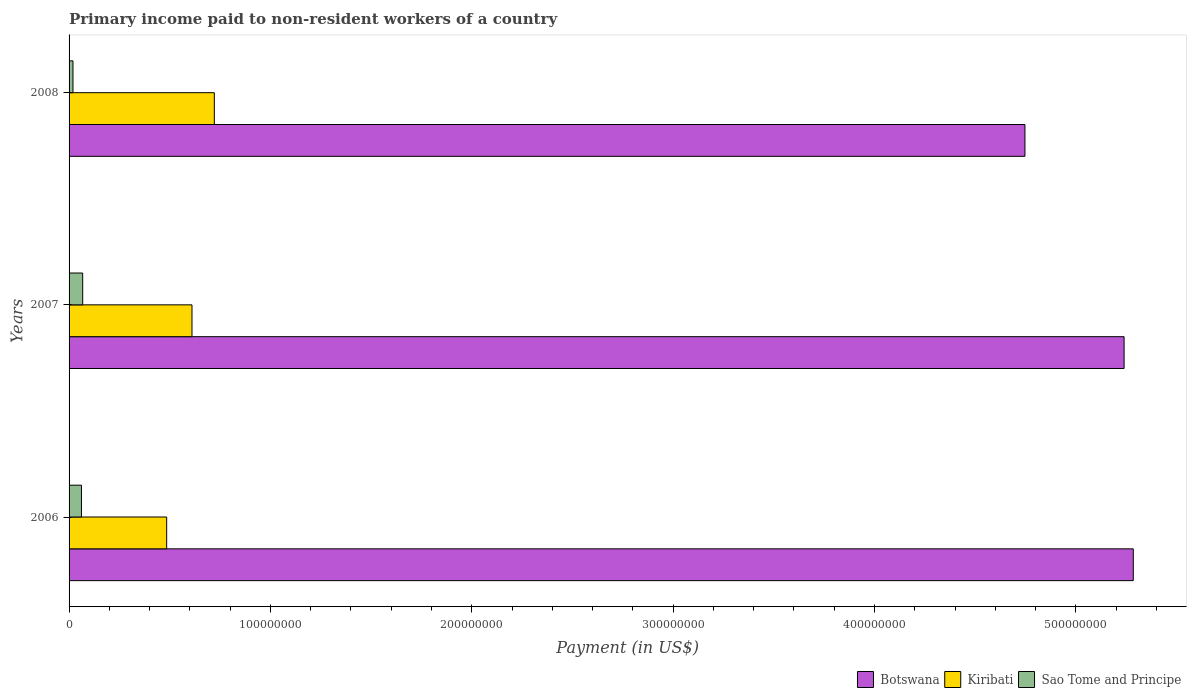How many different coloured bars are there?
Offer a terse response. 3. Are the number of bars per tick equal to the number of legend labels?
Keep it short and to the point. Yes. How many bars are there on the 3rd tick from the top?
Keep it short and to the point. 3. How many bars are there on the 3rd tick from the bottom?
Give a very brief answer. 3. In how many cases, is the number of bars for a given year not equal to the number of legend labels?
Your answer should be very brief. 0. What is the amount paid to workers in Sao Tome and Principe in 2007?
Your response must be concise. 6.76e+06. Across all years, what is the maximum amount paid to workers in Kiribati?
Keep it short and to the point. 7.21e+07. Across all years, what is the minimum amount paid to workers in Botswana?
Offer a very short reply. 4.75e+08. What is the total amount paid to workers in Kiribati in the graph?
Make the answer very short. 1.82e+08. What is the difference between the amount paid to workers in Sao Tome and Principe in 2006 and that in 2007?
Give a very brief answer. -6.11e+05. What is the difference between the amount paid to workers in Botswana in 2008 and the amount paid to workers in Kiribati in 2007?
Your answer should be compact. 4.14e+08. What is the average amount paid to workers in Botswana per year?
Your response must be concise. 5.09e+08. In the year 2006, what is the difference between the amount paid to workers in Botswana and amount paid to workers in Sao Tome and Principe?
Your answer should be compact. 5.22e+08. In how many years, is the amount paid to workers in Sao Tome and Principe greater than 500000000 US$?
Ensure brevity in your answer.  0. What is the ratio of the amount paid to workers in Botswana in 2006 to that in 2008?
Provide a short and direct response. 1.11. Is the amount paid to workers in Sao Tome and Principe in 2006 less than that in 2008?
Offer a very short reply. No. What is the difference between the highest and the second highest amount paid to workers in Botswana?
Give a very brief answer. 4.56e+06. What is the difference between the highest and the lowest amount paid to workers in Kiribati?
Keep it short and to the point. 2.37e+07. Is the sum of the amount paid to workers in Botswana in 2006 and 2007 greater than the maximum amount paid to workers in Kiribati across all years?
Offer a terse response. Yes. What does the 1st bar from the top in 2006 represents?
Provide a succinct answer. Sao Tome and Principe. What does the 2nd bar from the bottom in 2006 represents?
Make the answer very short. Kiribati. Is it the case that in every year, the sum of the amount paid to workers in Kiribati and amount paid to workers in Botswana is greater than the amount paid to workers in Sao Tome and Principe?
Your response must be concise. Yes. How many bars are there?
Ensure brevity in your answer.  9. Are all the bars in the graph horizontal?
Give a very brief answer. Yes. What is the difference between two consecutive major ticks on the X-axis?
Provide a succinct answer. 1.00e+08. Does the graph contain any zero values?
Provide a short and direct response. No. Does the graph contain grids?
Your answer should be compact. No. How many legend labels are there?
Offer a terse response. 3. What is the title of the graph?
Your response must be concise. Primary income paid to non-resident workers of a country. What is the label or title of the X-axis?
Give a very brief answer. Payment (in US$). What is the Payment (in US$) in Botswana in 2006?
Provide a succinct answer. 5.29e+08. What is the Payment (in US$) of Kiribati in 2006?
Provide a succinct answer. 4.85e+07. What is the Payment (in US$) in Sao Tome and Principe in 2006?
Make the answer very short. 6.15e+06. What is the Payment (in US$) of Botswana in 2007?
Your answer should be compact. 5.24e+08. What is the Payment (in US$) in Kiribati in 2007?
Make the answer very short. 6.10e+07. What is the Payment (in US$) in Sao Tome and Principe in 2007?
Provide a succinct answer. 6.76e+06. What is the Payment (in US$) in Botswana in 2008?
Your response must be concise. 4.75e+08. What is the Payment (in US$) of Kiribati in 2008?
Your response must be concise. 7.21e+07. What is the Payment (in US$) in Sao Tome and Principe in 2008?
Offer a terse response. 1.94e+06. Across all years, what is the maximum Payment (in US$) in Botswana?
Your response must be concise. 5.29e+08. Across all years, what is the maximum Payment (in US$) in Kiribati?
Provide a short and direct response. 7.21e+07. Across all years, what is the maximum Payment (in US$) in Sao Tome and Principe?
Provide a succinct answer. 6.76e+06. Across all years, what is the minimum Payment (in US$) in Botswana?
Your response must be concise. 4.75e+08. Across all years, what is the minimum Payment (in US$) in Kiribati?
Offer a very short reply. 4.85e+07. Across all years, what is the minimum Payment (in US$) of Sao Tome and Principe?
Make the answer very short. 1.94e+06. What is the total Payment (in US$) of Botswana in the graph?
Ensure brevity in your answer.  1.53e+09. What is the total Payment (in US$) in Kiribati in the graph?
Offer a terse response. 1.82e+08. What is the total Payment (in US$) in Sao Tome and Principe in the graph?
Make the answer very short. 1.49e+07. What is the difference between the Payment (in US$) in Botswana in 2006 and that in 2007?
Make the answer very short. 4.56e+06. What is the difference between the Payment (in US$) of Kiribati in 2006 and that in 2007?
Provide a short and direct response. -1.26e+07. What is the difference between the Payment (in US$) of Sao Tome and Principe in 2006 and that in 2007?
Provide a short and direct response. -6.11e+05. What is the difference between the Payment (in US$) in Botswana in 2006 and that in 2008?
Provide a succinct answer. 5.38e+07. What is the difference between the Payment (in US$) in Kiribati in 2006 and that in 2008?
Offer a terse response. -2.37e+07. What is the difference between the Payment (in US$) in Sao Tome and Principe in 2006 and that in 2008?
Your answer should be very brief. 4.21e+06. What is the difference between the Payment (in US$) of Botswana in 2007 and that in 2008?
Ensure brevity in your answer.  4.92e+07. What is the difference between the Payment (in US$) in Kiribati in 2007 and that in 2008?
Your answer should be very brief. -1.11e+07. What is the difference between the Payment (in US$) of Sao Tome and Principe in 2007 and that in 2008?
Make the answer very short. 4.83e+06. What is the difference between the Payment (in US$) of Botswana in 2006 and the Payment (in US$) of Kiribati in 2007?
Offer a terse response. 4.68e+08. What is the difference between the Payment (in US$) of Botswana in 2006 and the Payment (in US$) of Sao Tome and Principe in 2007?
Your answer should be very brief. 5.22e+08. What is the difference between the Payment (in US$) of Kiribati in 2006 and the Payment (in US$) of Sao Tome and Principe in 2007?
Provide a short and direct response. 4.17e+07. What is the difference between the Payment (in US$) in Botswana in 2006 and the Payment (in US$) in Kiribati in 2008?
Your answer should be very brief. 4.56e+08. What is the difference between the Payment (in US$) in Botswana in 2006 and the Payment (in US$) in Sao Tome and Principe in 2008?
Give a very brief answer. 5.27e+08. What is the difference between the Payment (in US$) in Kiribati in 2006 and the Payment (in US$) in Sao Tome and Principe in 2008?
Provide a short and direct response. 4.65e+07. What is the difference between the Payment (in US$) in Botswana in 2007 and the Payment (in US$) in Kiribati in 2008?
Offer a terse response. 4.52e+08. What is the difference between the Payment (in US$) in Botswana in 2007 and the Payment (in US$) in Sao Tome and Principe in 2008?
Your response must be concise. 5.22e+08. What is the difference between the Payment (in US$) in Kiribati in 2007 and the Payment (in US$) in Sao Tome and Principe in 2008?
Your answer should be compact. 5.91e+07. What is the average Payment (in US$) in Botswana per year?
Provide a succinct answer. 5.09e+08. What is the average Payment (in US$) of Kiribati per year?
Offer a very short reply. 6.06e+07. What is the average Payment (in US$) in Sao Tome and Principe per year?
Ensure brevity in your answer.  4.95e+06. In the year 2006, what is the difference between the Payment (in US$) of Botswana and Payment (in US$) of Kiribati?
Offer a terse response. 4.80e+08. In the year 2006, what is the difference between the Payment (in US$) of Botswana and Payment (in US$) of Sao Tome and Principe?
Keep it short and to the point. 5.22e+08. In the year 2006, what is the difference between the Payment (in US$) of Kiribati and Payment (in US$) of Sao Tome and Principe?
Keep it short and to the point. 4.23e+07. In the year 2007, what is the difference between the Payment (in US$) in Botswana and Payment (in US$) in Kiribati?
Ensure brevity in your answer.  4.63e+08. In the year 2007, what is the difference between the Payment (in US$) of Botswana and Payment (in US$) of Sao Tome and Principe?
Ensure brevity in your answer.  5.17e+08. In the year 2007, what is the difference between the Payment (in US$) in Kiribati and Payment (in US$) in Sao Tome and Principe?
Give a very brief answer. 5.43e+07. In the year 2008, what is the difference between the Payment (in US$) of Botswana and Payment (in US$) of Kiribati?
Make the answer very short. 4.03e+08. In the year 2008, what is the difference between the Payment (in US$) of Botswana and Payment (in US$) of Sao Tome and Principe?
Your answer should be very brief. 4.73e+08. In the year 2008, what is the difference between the Payment (in US$) of Kiribati and Payment (in US$) of Sao Tome and Principe?
Offer a very short reply. 7.02e+07. What is the ratio of the Payment (in US$) in Botswana in 2006 to that in 2007?
Give a very brief answer. 1.01. What is the ratio of the Payment (in US$) in Kiribati in 2006 to that in 2007?
Ensure brevity in your answer.  0.79. What is the ratio of the Payment (in US$) of Sao Tome and Principe in 2006 to that in 2007?
Keep it short and to the point. 0.91. What is the ratio of the Payment (in US$) in Botswana in 2006 to that in 2008?
Your answer should be compact. 1.11. What is the ratio of the Payment (in US$) of Kiribati in 2006 to that in 2008?
Offer a very short reply. 0.67. What is the ratio of the Payment (in US$) of Sao Tome and Principe in 2006 to that in 2008?
Provide a succinct answer. 3.17. What is the ratio of the Payment (in US$) in Botswana in 2007 to that in 2008?
Offer a very short reply. 1.1. What is the ratio of the Payment (in US$) of Kiribati in 2007 to that in 2008?
Give a very brief answer. 0.85. What is the ratio of the Payment (in US$) of Sao Tome and Principe in 2007 to that in 2008?
Provide a succinct answer. 3.49. What is the difference between the highest and the second highest Payment (in US$) in Botswana?
Provide a succinct answer. 4.56e+06. What is the difference between the highest and the second highest Payment (in US$) of Kiribati?
Your answer should be compact. 1.11e+07. What is the difference between the highest and the second highest Payment (in US$) of Sao Tome and Principe?
Offer a terse response. 6.11e+05. What is the difference between the highest and the lowest Payment (in US$) of Botswana?
Your answer should be compact. 5.38e+07. What is the difference between the highest and the lowest Payment (in US$) of Kiribati?
Keep it short and to the point. 2.37e+07. What is the difference between the highest and the lowest Payment (in US$) in Sao Tome and Principe?
Ensure brevity in your answer.  4.83e+06. 